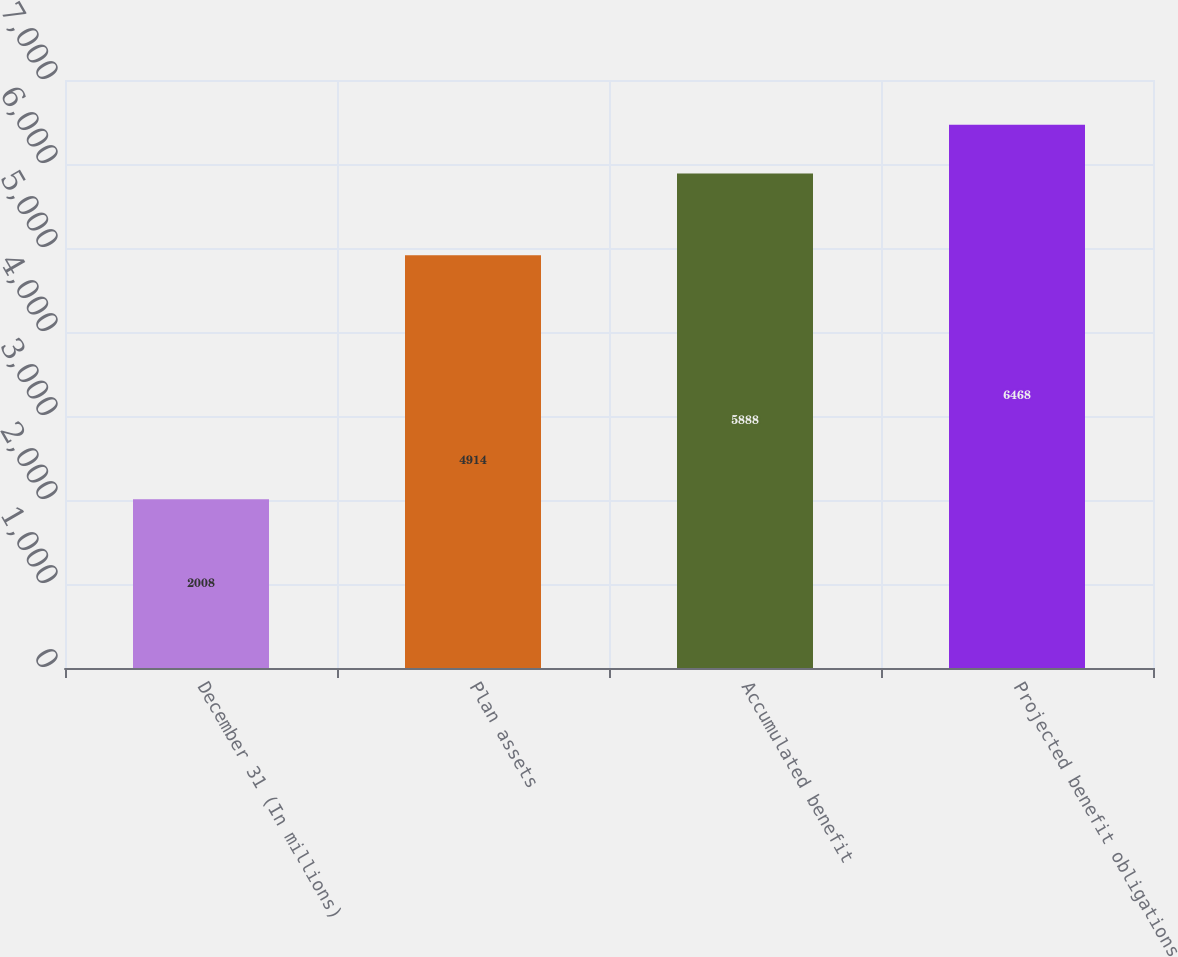Convert chart. <chart><loc_0><loc_0><loc_500><loc_500><bar_chart><fcel>December 31 (In millions)<fcel>Plan assets<fcel>Accumulated benefit<fcel>Projected benefit obligations<nl><fcel>2008<fcel>4914<fcel>5888<fcel>6468<nl></chart> 